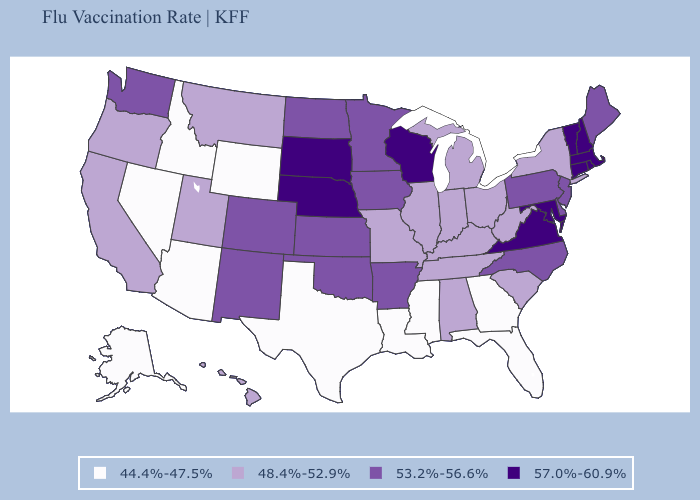Name the states that have a value in the range 57.0%-60.9%?
Give a very brief answer. Connecticut, Maryland, Massachusetts, Nebraska, New Hampshire, Rhode Island, South Dakota, Vermont, Virginia, Wisconsin. Does Maryland have the highest value in the South?
Write a very short answer. Yes. What is the value of Wyoming?
Concise answer only. 44.4%-47.5%. Name the states that have a value in the range 57.0%-60.9%?
Write a very short answer. Connecticut, Maryland, Massachusetts, Nebraska, New Hampshire, Rhode Island, South Dakota, Vermont, Virginia, Wisconsin. Does Rhode Island have the lowest value in the USA?
Write a very short answer. No. Among the states that border South Carolina , which have the lowest value?
Quick response, please. Georgia. Among the states that border Iowa , which have the highest value?
Short answer required. Nebraska, South Dakota, Wisconsin. Does Maryland have the same value as West Virginia?
Answer briefly. No. What is the value of Kentucky?
Concise answer only. 48.4%-52.9%. What is the value of North Carolina?
Quick response, please. 53.2%-56.6%. What is the value of New Hampshire?
Give a very brief answer. 57.0%-60.9%. Does the first symbol in the legend represent the smallest category?
Answer briefly. Yes. Does Connecticut have the highest value in the Northeast?
Concise answer only. Yes. Among the states that border South Dakota , which have the lowest value?
Short answer required. Wyoming. What is the lowest value in the MidWest?
Write a very short answer. 48.4%-52.9%. 